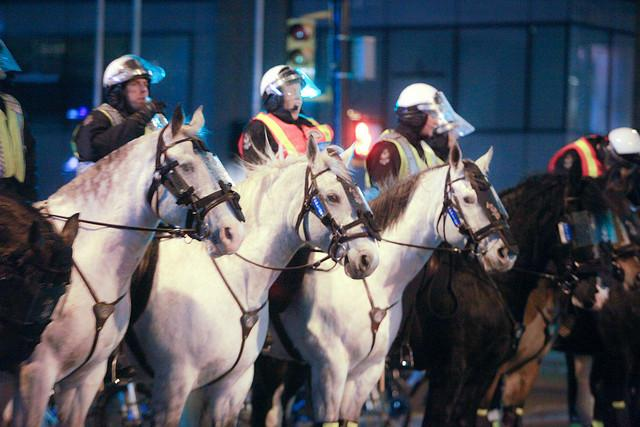What body part is protected by the attachment on the helmets they are wearing?

Choices:
A) arms
B) neck
C) throat
D) face face 